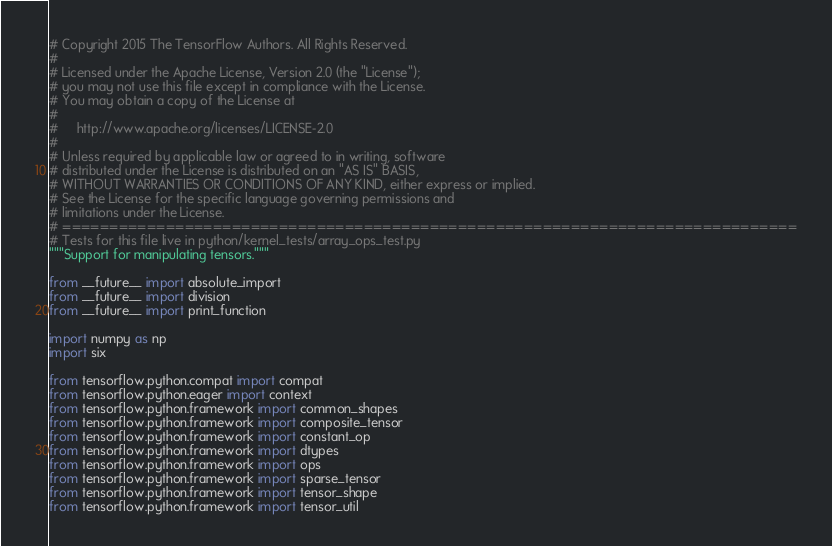<code> <loc_0><loc_0><loc_500><loc_500><_Python_># Copyright 2015 The TensorFlow Authors. All Rights Reserved.
#
# Licensed under the Apache License, Version 2.0 (the "License");
# you may not use this file except in compliance with the License.
# You may obtain a copy of the License at
#
#     http://www.apache.org/licenses/LICENSE-2.0
#
# Unless required by applicable law or agreed to in writing, software
# distributed under the License is distributed on an "AS IS" BASIS,
# WITHOUT WARRANTIES OR CONDITIONS OF ANY KIND, either express or implied.
# See the License for the specific language governing permissions and
# limitations under the License.
# ==============================================================================
# Tests for this file live in python/kernel_tests/array_ops_test.py
"""Support for manipulating tensors."""

from __future__ import absolute_import
from __future__ import division
from __future__ import print_function

import numpy as np
import six

from tensorflow.python.compat import compat
from tensorflow.python.eager import context
from tensorflow.python.framework import common_shapes
from tensorflow.python.framework import composite_tensor
from tensorflow.python.framework import constant_op
from tensorflow.python.framework import dtypes
from tensorflow.python.framework import ops
from tensorflow.python.framework import sparse_tensor
from tensorflow.python.framework import tensor_shape
from tensorflow.python.framework import tensor_util</code> 